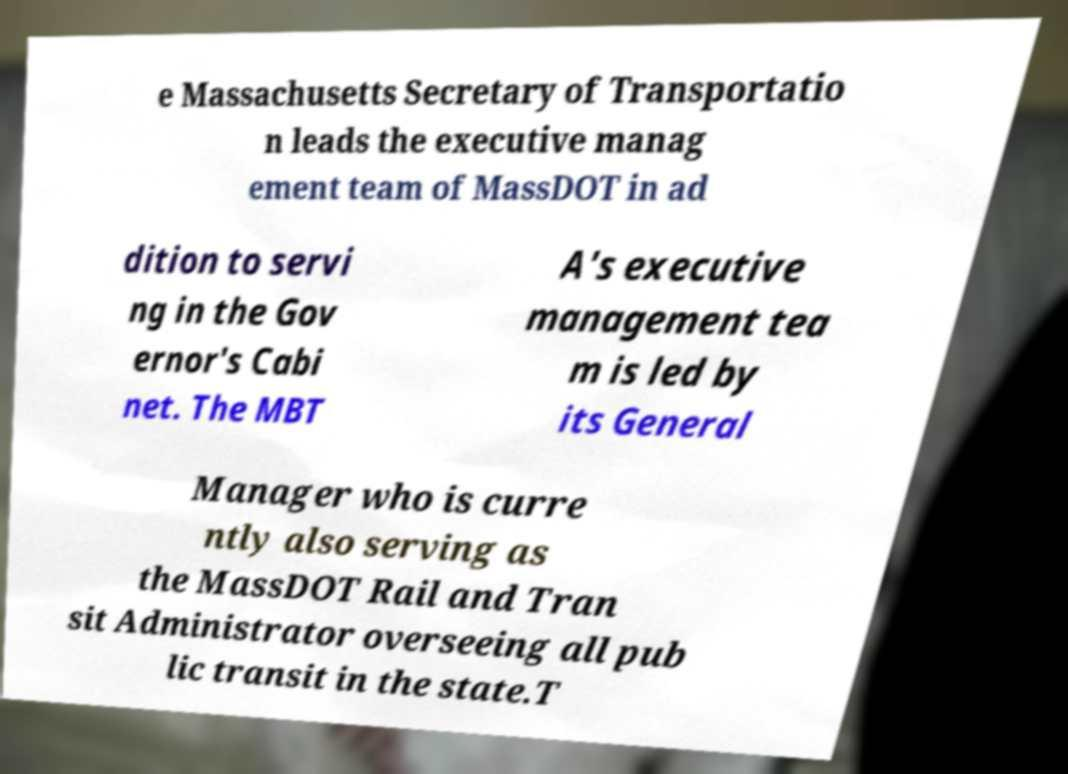Can you accurately transcribe the text from the provided image for me? e Massachusetts Secretary of Transportatio n leads the executive manag ement team of MassDOT in ad dition to servi ng in the Gov ernor's Cabi net. The MBT A's executive management tea m is led by its General Manager who is curre ntly also serving as the MassDOT Rail and Tran sit Administrator overseeing all pub lic transit in the state.T 